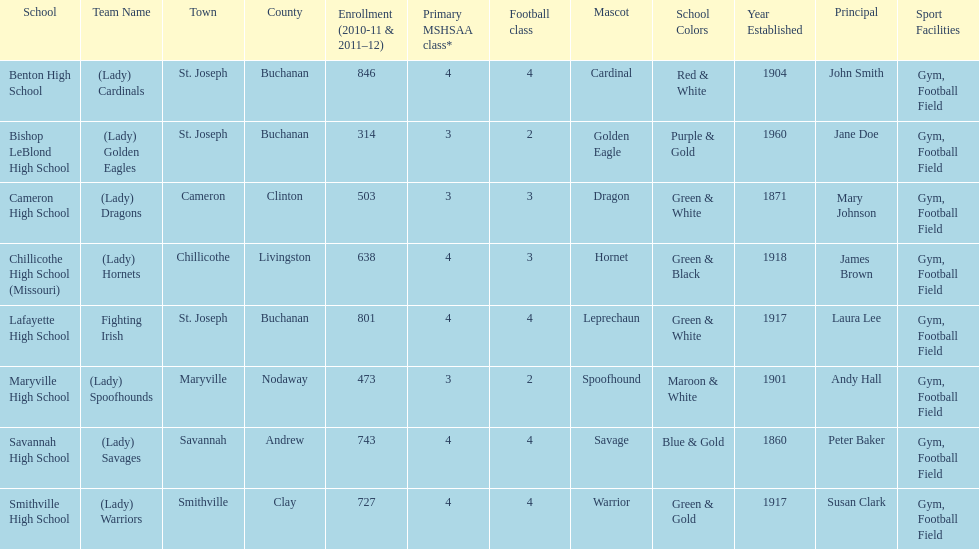Benton high school and bishop leblond high school are both located in what town? St. Joseph. 